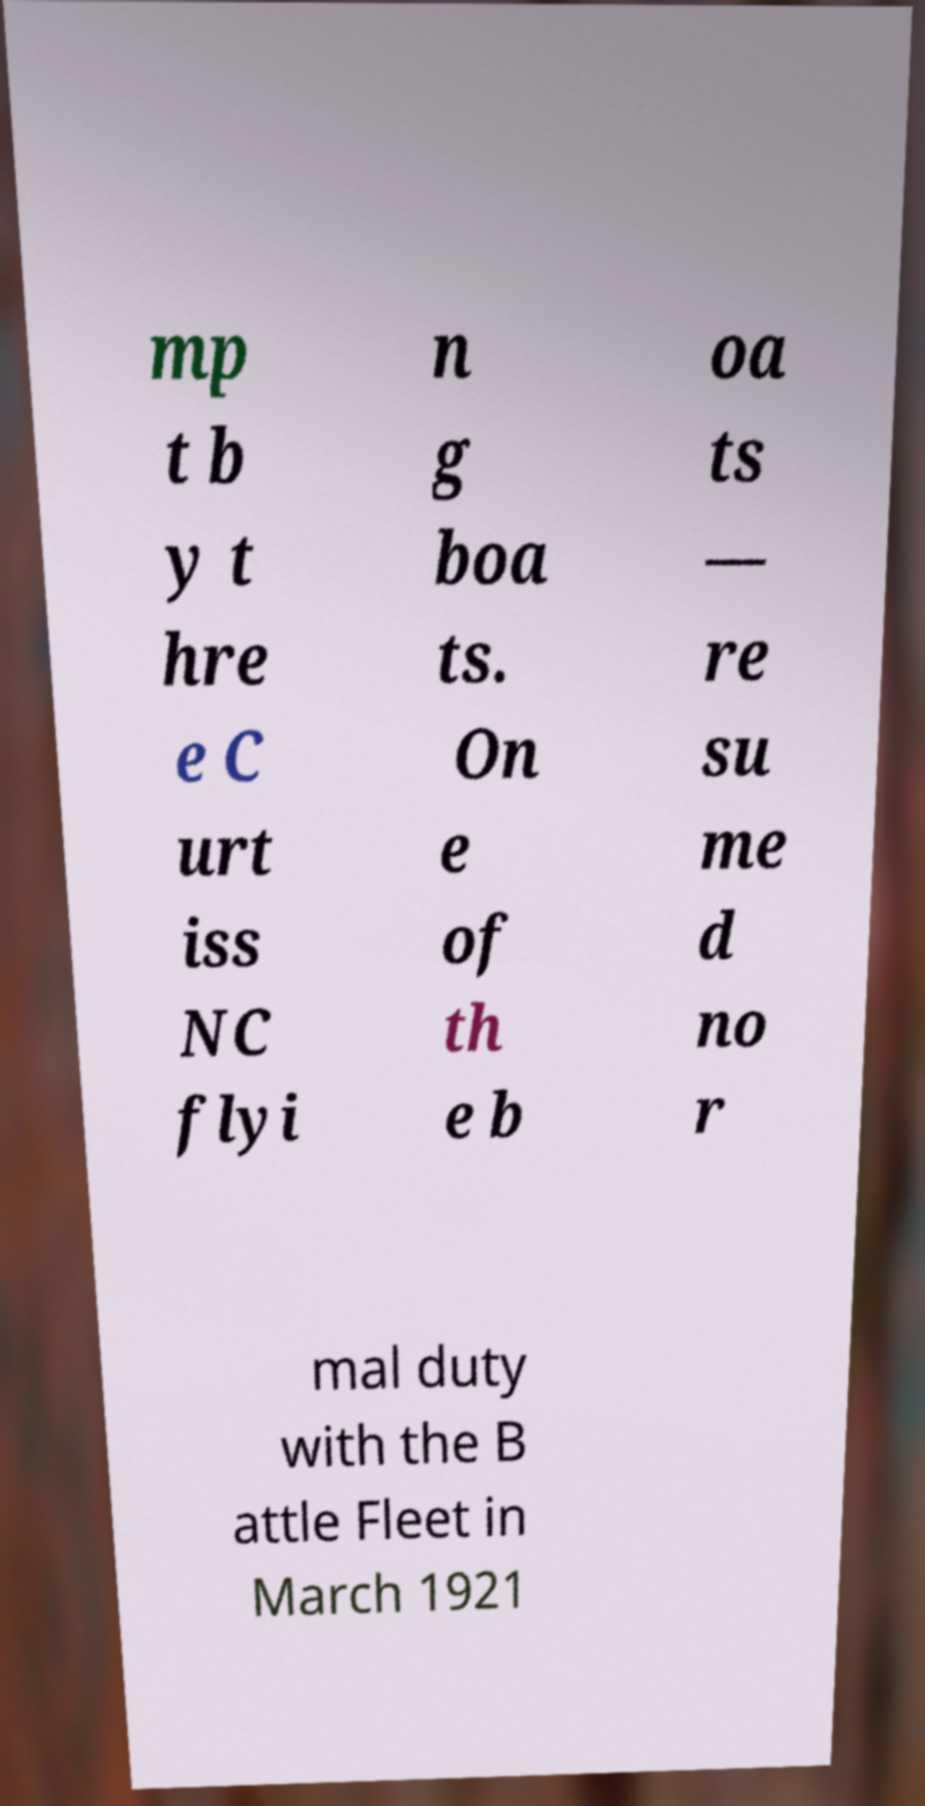Please read and relay the text visible in this image. What does it say? mp t b y t hre e C urt iss NC flyi n g boa ts. On e of th e b oa ts — re su me d no r mal duty with the B attle Fleet in March 1921 